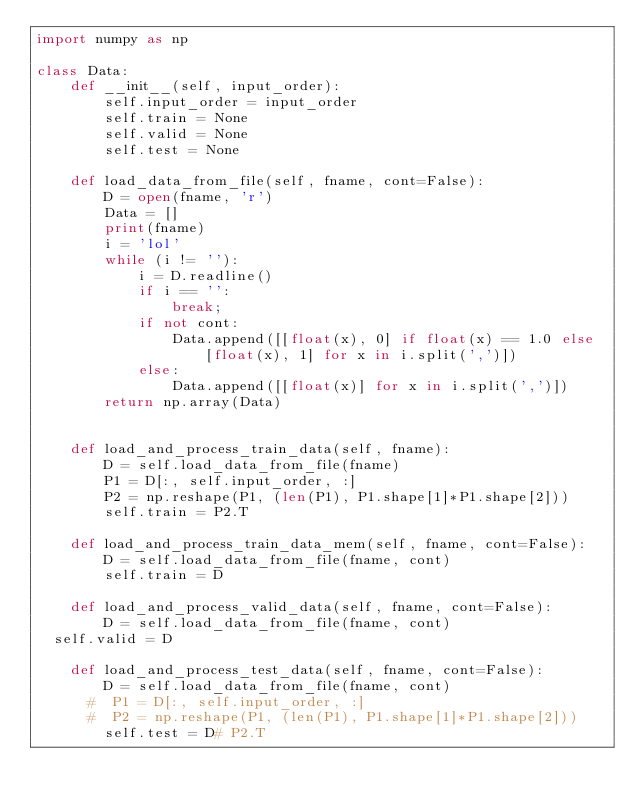Convert code to text. <code><loc_0><loc_0><loc_500><loc_500><_Python_>import numpy as np

class Data:
    def __init__(self, input_order):
        self.input_order = input_order
        self.train = None
        self.valid = None
        self.test = None

    def load_data_from_file(self, fname, cont=False):
        D = open(fname, 'r')
        Data = []
        print(fname)
        i = 'lol'
        while (i != ''):
            i = D.readline()
            if i == '':
                break;
            if not cont:
                Data.append([[float(x), 0] if float(x) == 1.0 else [float(x), 1] for x in i.split(',')])
            else:
                Data.append([[float(x)] for x in i.split(',')])
        return np.array(Data)


    def load_and_process_train_data(self, fname):
        D = self.load_data_from_file(fname)
        P1 = D[:, self.input_order, :]
        P2 = np.reshape(P1, (len(P1), P1.shape[1]*P1.shape[2]))
        self.train = P2.T

    def load_and_process_train_data_mem(self, fname, cont=False):
        D = self.load_data_from_file(fname, cont)
        self.train = D

    def load_and_process_valid_data(self, fname, cont=False):
        D = self.load_data_from_file(fname, cont)
	self.valid = D

    def load_and_process_test_data(self, fname, cont=False):
        D = self.load_data_from_file(fname, cont)
      #  P1 = D[:, self.input_order, :]
      #  P2 = np.reshape(P1, (len(P1), P1.shape[1]*P1.shape[2]))
        self.test = D# P2.T
        
</code> 